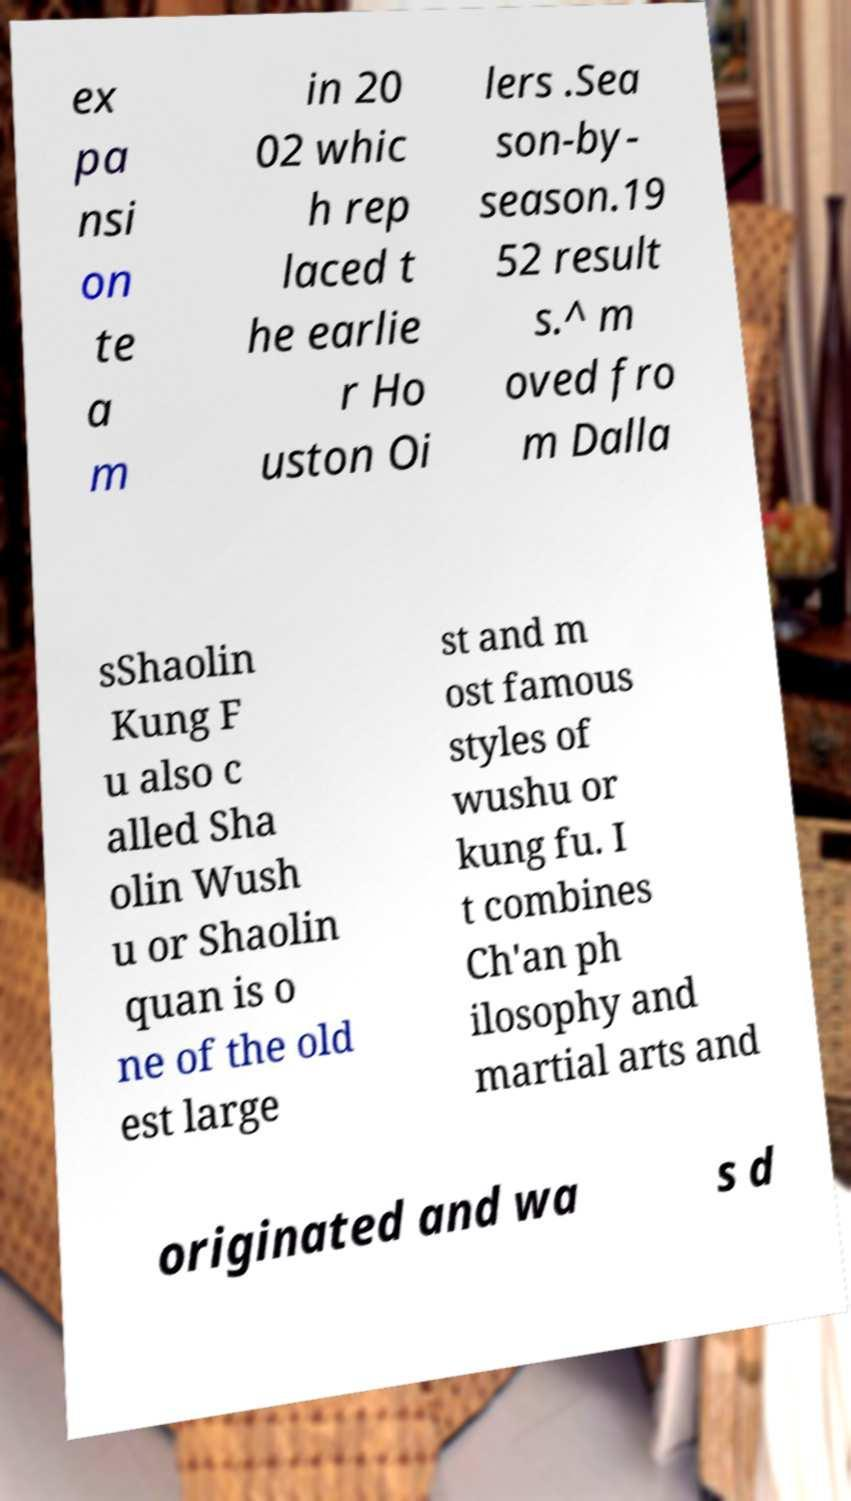Could you extract and type out the text from this image? ex pa nsi on te a m in 20 02 whic h rep laced t he earlie r Ho uston Oi lers .Sea son-by- season.19 52 result s.^ m oved fro m Dalla sShaolin Kung F u also c alled Sha olin Wush u or Shaolin quan is o ne of the old est large st and m ost famous styles of wushu or kung fu. I t combines Ch'an ph ilosophy and martial arts and originated and wa s d 